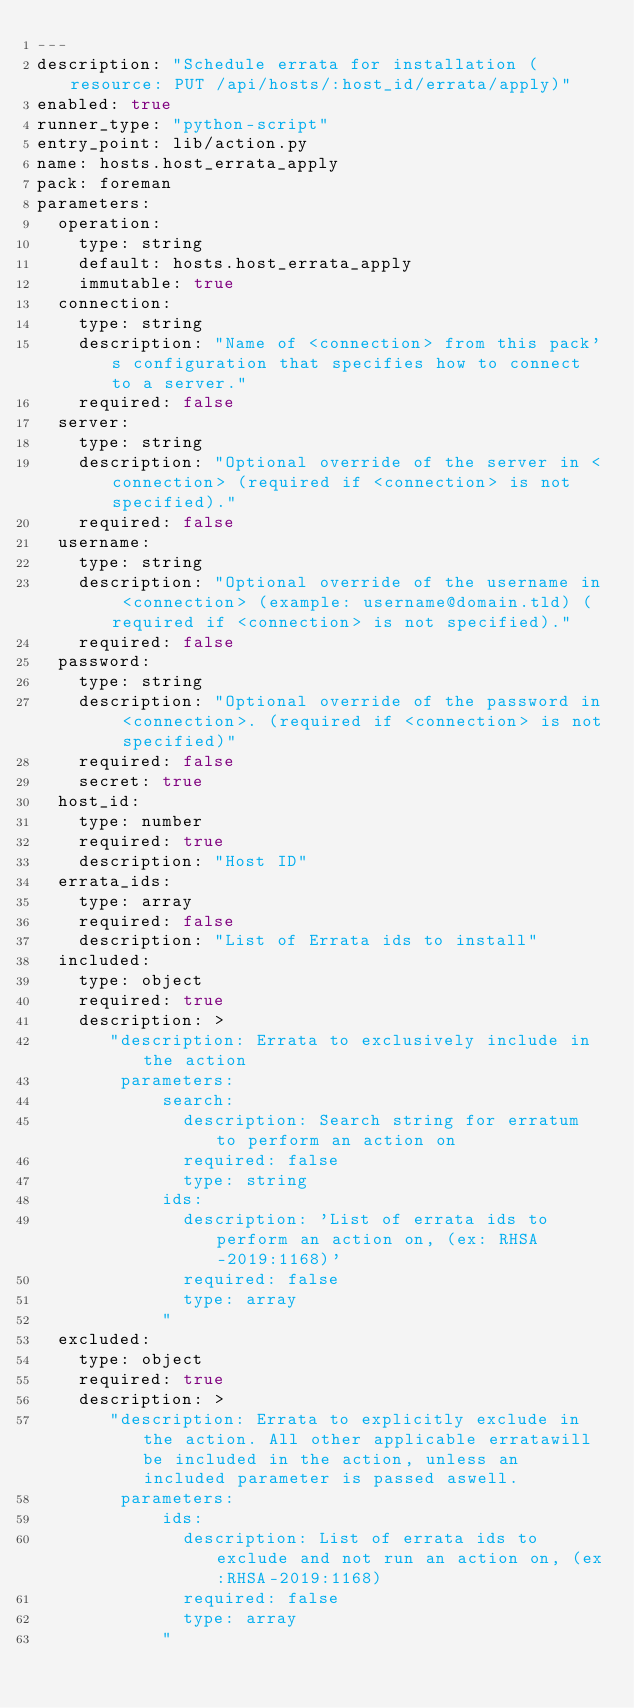Convert code to text. <code><loc_0><loc_0><loc_500><loc_500><_YAML_>---
description: "Schedule errata for installation (resource: PUT /api/hosts/:host_id/errata/apply)"
enabled: true
runner_type: "python-script"
entry_point: lib/action.py
name: hosts.host_errata_apply
pack: foreman
parameters:
  operation:
    type: string
    default: hosts.host_errata_apply
    immutable: true
  connection:
    type: string
    description: "Name of <connection> from this pack's configuration that specifies how to connect to a server."
    required: false
  server:
    type: string
    description: "Optional override of the server in <connection> (required if <connection> is not specified)."
    required: false
  username:
    type: string
    description: "Optional override of the username in <connection> (example: username@domain.tld) (required if <connection> is not specified)."
    required: false
  password:
    type: string
    description: "Optional override of the password in <connection>. (required if <connection> is not specified)"
    required: false
    secret: true
  host_id:
    type: number
    required: true
    description: "Host ID"
  errata_ids:
    type: array
    required: false
    description: "List of Errata ids to install"
  included:
    type: object
    required: true
    description: >
       "description: Errata to exclusively include in the action
        parameters:
            search:
              description: Search string for erratum to perform an action on
              required: false
              type: string
            ids:
              description: 'List of errata ids to perform an action on, (ex: RHSA-2019:1168)'
              required: false
              type: array
            "
  excluded:
    type: object
    required: true
    description: >
       "description: Errata to explicitly exclude in the action. All other applicable erratawill be included in the action, unless an included parameter is passed aswell.
        parameters:
            ids:
              description: List of errata ids to exclude and not run an action on, (ex:RHSA-2019:1168)
              required: false
              type: array
            "</code> 